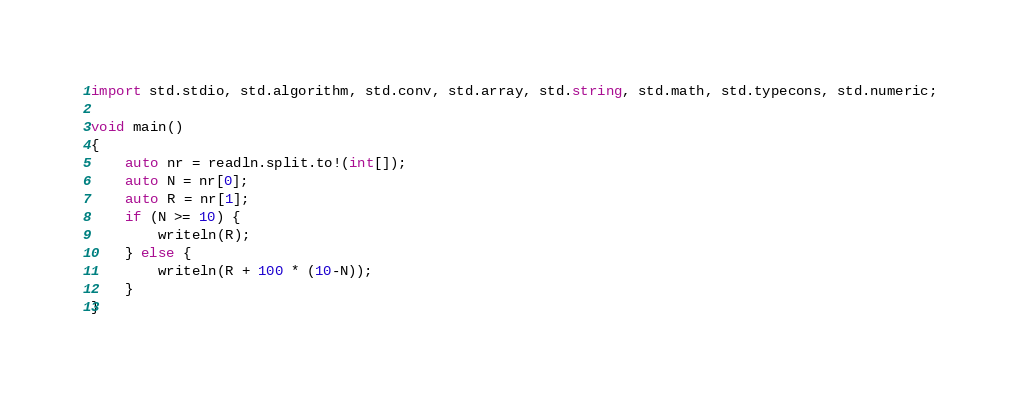Convert code to text. <code><loc_0><loc_0><loc_500><loc_500><_D_>import std.stdio, std.algorithm, std.conv, std.array, std.string, std.math, std.typecons, std.numeric;

void main()
{
    auto nr = readln.split.to!(int[]);
    auto N = nr[0];
    auto R = nr[1];
    if (N >= 10) {
        writeln(R);
    } else {
        writeln(R + 100 * (10-N));
    }
}</code> 